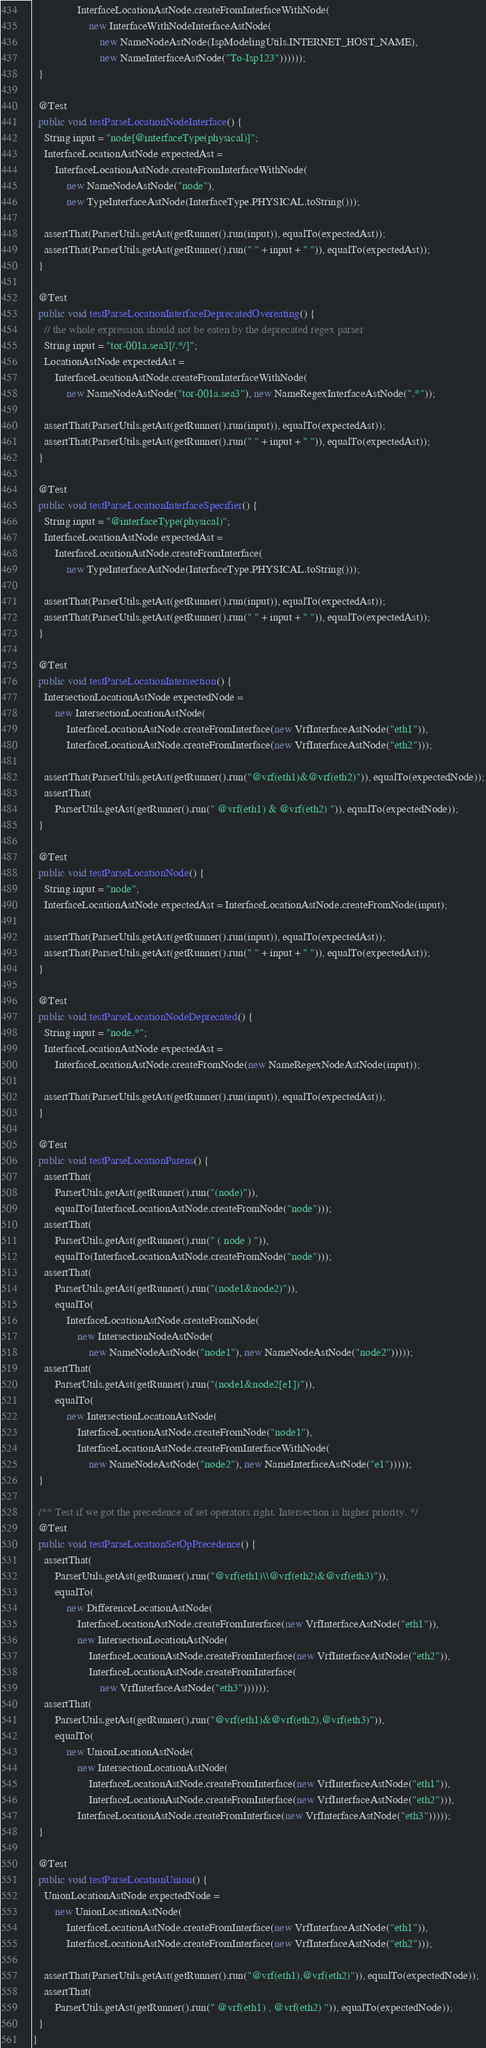<code> <loc_0><loc_0><loc_500><loc_500><_Java_>                InterfaceLocationAstNode.createFromInterfaceWithNode(
                    new InterfaceWithNodeInterfaceAstNode(
                        new NameNodeAstNode(IspModelingUtils.INTERNET_HOST_NAME),
                        new NameInterfaceAstNode("To-Isp123"))))));
  }

  @Test
  public void testParseLocationNodeInterface() {
    String input = "node[@interfaceType(physical)]";
    InterfaceLocationAstNode expectedAst =
        InterfaceLocationAstNode.createFromInterfaceWithNode(
            new NameNodeAstNode("node"),
            new TypeInterfaceAstNode(InterfaceType.PHYSICAL.toString()));

    assertThat(ParserUtils.getAst(getRunner().run(input)), equalTo(expectedAst));
    assertThat(ParserUtils.getAst(getRunner().run(" " + input + " ")), equalTo(expectedAst));
  }

  @Test
  public void testParseLocationInterfaceDeprecatedOvereating() {
    // the whole expression should not be eaten by the deprecated regex parser
    String input = "tor-001a.sea3[/.*/]";
    LocationAstNode expectedAst =
        InterfaceLocationAstNode.createFromInterfaceWithNode(
            new NameNodeAstNode("tor-001a.sea3"), new NameRegexInterfaceAstNode(".*"));

    assertThat(ParserUtils.getAst(getRunner().run(input)), equalTo(expectedAst));
    assertThat(ParserUtils.getAst(getRunner().run(" " + input + " ")), equalTo(expectedAst));
  }

  @Test
  public void testParseLocationInterfaceSpecifier() {
    String input = "@interfaceType(physical)";
    InterfaceLocationAstNode expectedAst =
        InterfaceLocationAstNode.createFromInterface(
            new TypeInterfaceAstNode(InterfaceType.PHYSICAL.toString()));

    assertThat(ParserUtils.getAst(getRunner().run(input)), equalTo(expectedAst));
    assertThat(ParserUtils.getAst(getRunner().run(" " + input + " ")), equalTo(expectedAst));
  }

  @Test
  public void testParseLocationIntersection() {
    IntersectionLocationAstNode expectedNode =
        new IntersectionLocationAstNode(
            InterfaceLocationAstNode.createFromInterface(new VrfInterfaceAstNode("eth1")),
            InterfaceLocationAstNode.createFromInterface(new VrfInterfaceAstNode("eth2")));

    assertThat(ParserUtils.getAst(getRunner().run("@vrf(eth1)&@vrf(eth2)")), equalTo(expectedNode));
    assertThat(
        ParserUtils.getAst(getRunner().run(" @vrf(eth1) & @vrf(eth2) ")), equalTo(expectedNode));
  }

  @Test
  public void testParseLocationNode() {
    String input = "node";
    InterfaceLocationAstNode expectedAst = InterfaceLocationAstNode.createFromNode(input);

    assertThat(ParserUtils.getAst(getRunner().run(input)), equalTo(expectedAst));
    assertThat(ParserUtils.getAst(getRunner().run(" " + input + " ")), equalTo(expectedAst));
  }

  @Test
  public void testParseLocationNodeDeprecated() {
    String input = "node.*";
    InterfaceLocationAstNode expectedAst =
        InterfaceLocationAstNode.createFromNode(new NameRegexNodeAstNode(input));

    assertThat(ParserUtils.getAst(getRunner().run(input)), equalTo(expectedAst));
  }

  @Test
  public void testParseLocationParens() {
    assertThat(
        ParserUtils.getAst(getRunner().run("(node)")),
        equalTo(InterfaceLocationAstNode.createFromNode("node")));
    assertThat(
        ParserUtils.getAst(getRunner().run(" ( node ) ")),
        equalTo(InterfaceLocationAstNode.createFromNode("node")));
    assertThat(
        ParserUtils.getAst(getRunner().run("(node1&node2)")),
        equalTo(
            InterfaceLocationAstNode.createFromNode(
                new IntersectionNodeAstNode(
                    new NameNodeAstNode("node1"), new NameNodeAstNode("node2")))));
    assertThat(
        ParserUtils.getAst(getRunner().run("(node1&node2[e1])")),
        equalTo(
            new IntersectionLocationAstNode(
                InterfaceLocationAstNode.createFromNode("node1"),
                InterfaceLocationAstNode.createFromInterfaceWithNode(
                    new NameNodeAstNode("node2"), new NameInterfaceAstNode("e1")))));
  }

  /** Test if we got the precedence of set operators right. Intersection is higher priority. */
  @Test
  public void testParseLocationSetOpPrecedence() {
    assertThat(
        ParserUtils.getAst(getRunner().run("@vrf(eth1)\\@vrf(eth2)&@vrf(eth3)")),
        equalTo(
            new DifferenceLocationAstNode(
                InterfaceLocationAstNode.createFromInterface(new VrfInterfaceAstNode("eth1")),
                new IntersectionLocationAstNode(
                    InterfaceLocationAstNode.createFromInterface(new VrfInterfaceAstNode("eth2")),
                    InterfaceLocationAstNode.createFromInterface(
                        new VrfInterfaceAstNode("eth3"))))));
    assertThat(
        ParserUtils.getAst(getRunner().run("@vrf(eth1)&@vrf(eth2),@vrf(eth3)")),
        equalTo(
            new UnionLocationAstNode(
                new IntersectionLocationAstNode(
                    InterfaceLocationAstNode.createFromInterface(new VrfInterfaceAstNode("eth1")),
                    InterfaceLocationAstNode.createFromInterface(new VrfInterfaceAstNode("eth2"))),
                InterfaceLocationAstNode.createFromInterface(new VrfInterfaceAstNode("eth3")))));
  }

  @Test
  public void testParseLocationUnion() {
    UnionLocationAstNode expectedNode =
        new UnionLocationAstNode(
            InterfaceLocationAstNode.createFromInterface(new VrfInterfaceAstNode("eth1")),
            InterfaceLocationAstNode.createFromInterface(new VrfInterfaceAstNode("eth2")));

    assertThat(ParserUtils.getAst(getRunner().run("@vrf(eth1),@vrf(eth2)")), equalTo(expectedNode));
    assertThat(
        ParserUtils.getAst(getRunner().run(" @vrf(eth1) , @vrf(eth2) ")), equalTo(expectedNode));
  }
}
</code> 